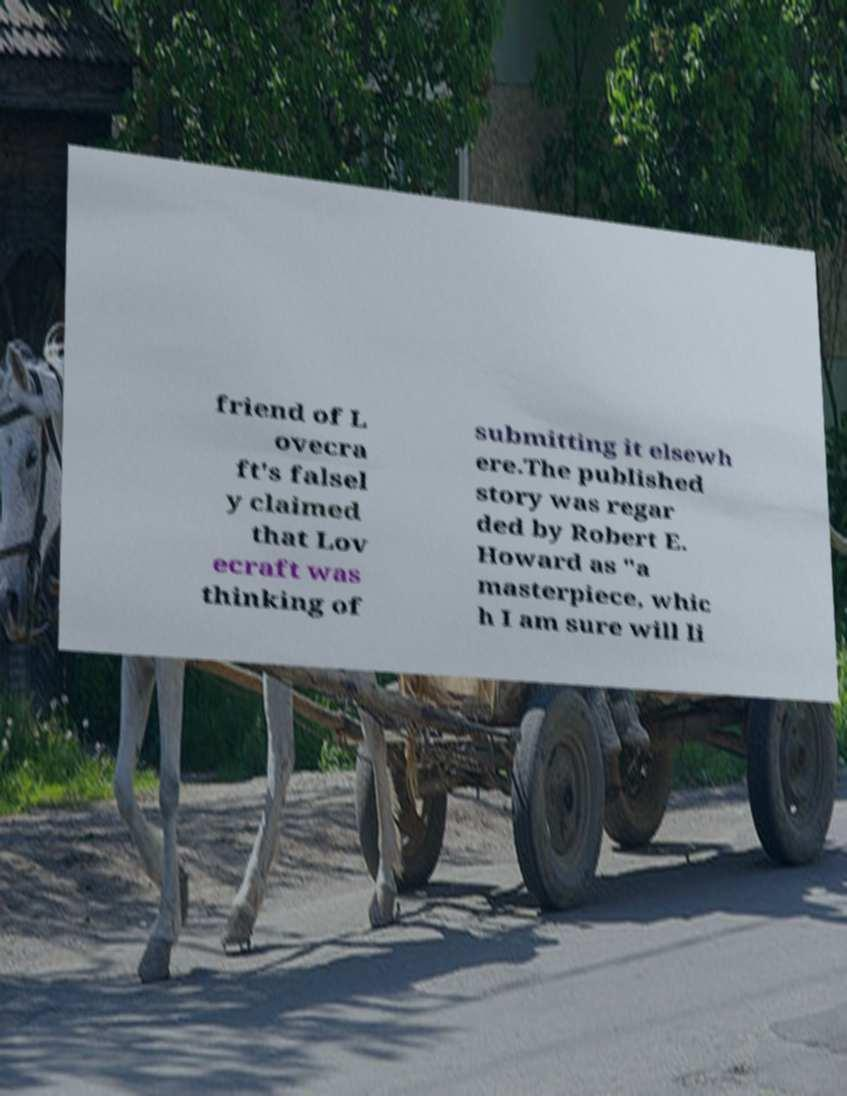Could you assist in decoding the text presented in this image and type it out clearly? friend of L ovecra ft's falsel y claimed that Lov ecraft was thinking of submitting it elsewh ere.The published story was regar ded by Robert E. Howard as "a masterpiece, whic h I am sure will li 